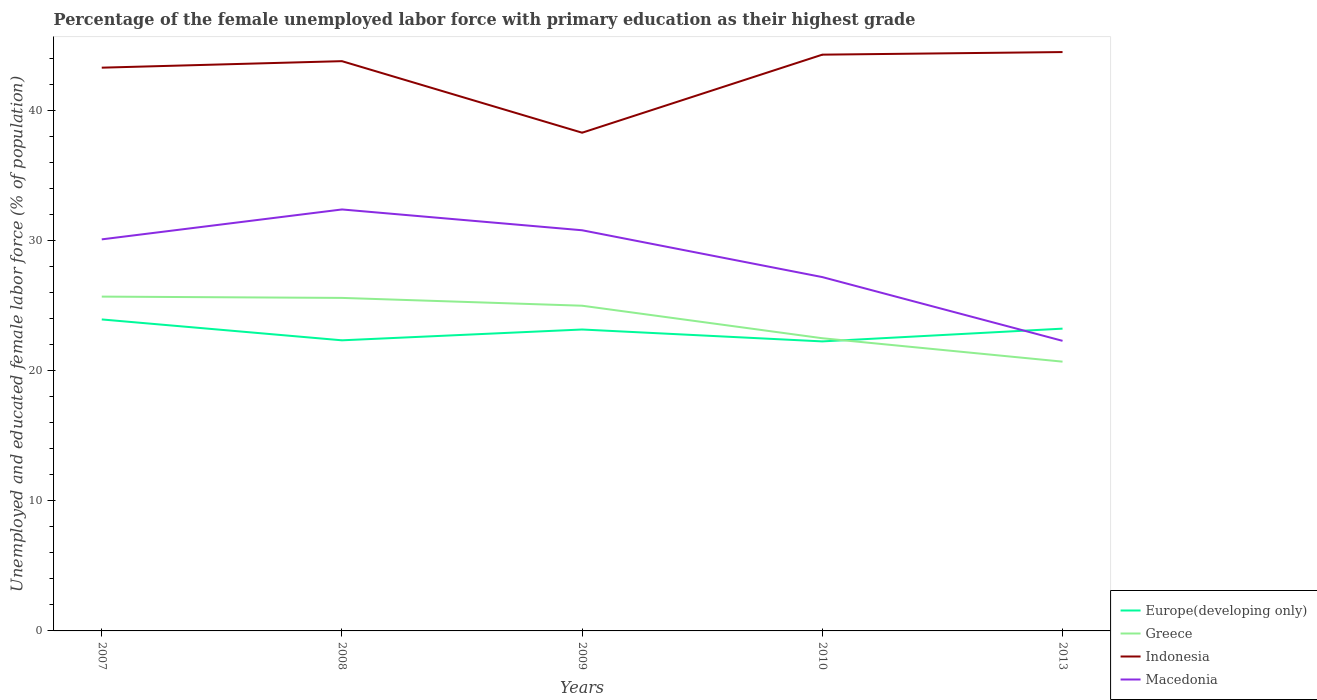Across all years, what is the maximum percentage of the unemployed female labor force with primary education in Indonesia?
Give a very brief answer. 38.3. In which year was the percentage of the unemployed female labor force with primary education in Greece maximum?
Provide a short and direct response. 2013. What is the total percentage of the unemployed female labor force with primary education in Europe(developing only) in the graph?
Your answer should be very brief. -0.83. What is the difference between the highest and the second highest percentage of the unemployed female labor force with primary education in Greece?
Provide a short and direct response. 5. Is the percentage of the unemployed female labor force with primary education in Europe(developing only) strictly greater than the percentage of the unemployed female labor force with primary education in Indonesia over the years?
Provide a succinct answer. Yes. How many lines are there?
Your response must be concise. 4. How many years are there in the graph?
Your answer should be very brief. 5. What is the difference between two consecutive major ticks on the Y-axis?
Your answer should be compact. 10. Where does the legend appear in the graph?
Offer a very short reply. Bottom right. How are the legend labels stacked?
Make the answer very short. Vertical. What is the title of the graph?
Provide a succinct answer. Percentage of the female unemployed labor force with primary education as their highest grade. Does "Netherlands" appear as one of the legend labels in the graph?
Give a very brief answer. No. What is the label or title of the X-axis?
Your response must be concise. Years. What is the label or title of the Y-axis?
Give a very brief answer. Unemployed and educated female labor force (% of population). What is the Unemployed and educated female labor force (% of population) of Europe(developing only) in 2007?
Ensure brevity in your answer.  23.95. What is the Unemployed and educated female labor force (% of population) of Greece in 2007?
Offer a very short reply. 25.7. What is the Unemployed and educated female labor force (% of population) in Indonesia in 2007?
Your response must be concise. 43.3. What is the Unemployed and educated female labor force (% of population) in Macedonia in 2007?
Ensure brevity in your answer.  30.1. What is the Unemployed and educated female labor force (% of population) in Europe(developing only) in 2008?
Your answer should be compact. 22.34. What is the Unemployed and educated female labor force (% of population) in Greece in 2008?
Offer a terse response. 25.6. What is the Unemployed and educated female labor force (% of population) in Indonesia in 2008?
Your response must be concise. 43.8. What is the Unemployed and educated female labor force (% of population) of Macedonia in 2008?
Make the answer very short. 32.4. What is the Unemployed and educated female labor force (% of population) of Europe(developing only) in 2009?
Offer a very short reply. 23.17. What is the Unemployed and educated female labor force (% of population) in Indonesia in 2009?
Provide a short and direct response. 38.3. What is the Unemployed and educated female labor force (% of population) in Macedonia in 2009?
Keep it short and to the point. 30.8. What is the Unemployed and educated female labor force (% of population) of Europe(developing only) in 2010?
Offer a terse response. 22.26. What is the Unemployed and educated female labor force (% of population) in Greece in 2010?
Your answer should be compact. 22.5. What is the Unemployed and educated female labor force (% of population) in Indonesia in 2010?
Keep it short and to the point. 44.3. What is the Unemployed and educated female labor force (% of population) in Macedonia in 2010?
Give a very brief answer. 27.2. What is the Unemployed and educated female labor force (% of population) in Europe(developing only) in 2013?
Offer a very short reply. 23.24. What is the Unemployed and educated female labor force (% of population) in Greece in 2013?
Ensure brevity in your answer.  20.7. What is the Unemployed and educated female labor force (% of population) in Indonesia in 2013?
Make the answer very short. 44.5. What is the Unemployed and educated female labor force (% of population) in Macedonia in 2013?
Keep it short and to the point. 22.3. Across all years, what is the maximum Unemployed and educated female labor force (% of population) of Europe(developing only)?
Your response must be concise. 23.95. Across all years, what is the maximum Unemployed and educated female labor force (% of population) in Greece?
Make the answer very short. 25.7. Across all years, what is the maximum Unemployed and educated female labor force (% of population) in Indonesia?
Your answer should be very brief. 44.5. Across all years, what is the maximum Unemployed and educated female labor force (% of population) of Macedonia?
Provide a short and direct response. 32.4. Across all years, what is the minimum Unemployed and educated female labor force (% of population) of Europe(developing only)?
Provide a succinct answer. 22.26. Across all years, what is the minimum Unemployed and educated female labor force (% of population) in Greece?
Your answer should be compact. 20.7. Across all years, what is the minimum Unemployed and educated female labor force (% of population) in Indonesia?
Keep it short and to the point. 38.3. Across all years, what is the minimum Unemployed and educated female labor force (% of population) in Macedonia?
Provide a short and direct response. 22.3. What is the total Unemployed and educated female labor force (% of population) of Europe(developing only) in the graph?
Offer a terse response. 114.95. What is the total Unemployed and educated female labor force (% of population) in Greece in the graph?
Give a very brief answer. 119.5. What is the total Unemployed and educated female labor force (% of population) of Indonesia in the graph?
Make the answer very short. 214.2. What is the total Unemployed and educated female labor force (% of population) of Macedonia in the graph?
Provide a succinct answer. 142.8. What is the difference between the Unemployed and educated female labor force (% of population) of Europe(developing only) in 2007 and that in 2008?
Your answer should be very brief. 1.6. What is the difference between the Unemployed and educated female labor force (% of population) in Greece in 2007 and that in 2008?
Your answer should be very brief. 0.1. What is the difference between the Unemployed and educated female labor force (% of population) of Europe(developing only) in 2007 and that in 2009?
Offer a terse response. 0.77. What is the difference between the Unemployed and educated female labor force (% of population) in Indonesia in 2007 and that in 2009?
Keep it short and to the point. 5. What is the difference between the Unemployed and educated female labor force (% of population) of Macedonia in 2007 and that in 2009?
Make the answer very short. -0.7. What is the difference between the Unemployed and educated female labor force (% of population) in Europe(developing only) in 2007 and that in 2010?
Make the answer very short. 1.69. What is the difference between the Unemployed and educated female labor force (% of population) of Greece in 2007 and that in 2010?
Offer a terse response. 3.2. What is the difference between the Unemployed and educated female labor force (% of population) of Europe(developing only) in 2007 and that in 2013?
Keep it short and to the point. 0.71. What is the difference between the Unemployed and educated female labor force (% of population) of Greece in 2007 and that in 2013?
Your answer should be very brief. 5. What is the difference between the Unemployed and educated female labor force (% of population) of Indonesia in 2007 and that in 2013?
Provide a succinct answer. -1.2. What is the difference between the Unemployed and educated female labor force (% of population) of Europe(developing only) in 2008 and that in 2009?
Give a very brief answer. -0.83. What is the difference between the Unemployed and educated female labor force (% of population) in Greece in 2008 and that in 2009?
Your response must be concise. 0.6. What is the difference between the Unemployed and educated female labor force (% of population) in Indonesia in 2008 and that in 2009?
Your answer should be very brief. 5.5. What is the difference between the Unemployed and educated female labor force (% of population) of Macedonia in 2008 and that in 2009?
Provide a succinct answer. 1.6. What is the difference between the Unemployed and educated female labor force (% of population) of Europe(developing only) in 2008 and that in 2010?
Provide a short and direct response. 0.08. What is the difference between the Unemployed and educated female labor force (% of population) of Europe(developing only) in 2008 and that in 2013?
Your answer should be compact. -0.9. What is the difference between the Unemployed and educated female labor force (% of population) in Greece in 2008 and that in 2013?
Offer a very short reply. 4.9. What is the difference between the Unemployed and educated female labor force (% of population) of Macedonia in 2008 and that in 2013?
Provide a short and direct response. 10.1. What is the difference between the Unemployed and educated female labor force (% of population) of Europe(developing only) in 2009 and that in 2010?
Provide a short and direct response. 0.92. What is the difference between the Unemployed and educated female labor force (% of population) of Macedonia in 2009 and that in 2010?
Keep it short and to the point. 3.6. What is the difference between the Unemployed and educated female labor force (% of population) of Europe(developing only) in 2009 and that in 2013?
Give a very brief answer. -0.07. What is the difference between the Unemployed and educated female labor force (% of population) of Europe(developing only) in 2010 and that in 2013?
Offer a terse response. -0.98. What is the difference between the Unemployed and educated female labor force (% of population) of Europe(developing only) in 2007 and the Unemployed and educated female labor force (% of population) of Greece in 2008?
Offer a terse response. -1.65. What is the difference between the Unemployed and educated female labor force (% of population) in Europe(developing only) in 2007 and the Unemployed and educated female labor force (% of population) in Indonesia in 2008?
Your answer should be compact. -19.85. What is the difference between the Unemployed and educated female labor force (% of population) in Europe(developing only) in 2007 and the Unemployed and educated female labor force (% of population) in Macedonia in 2008?
Ensure brevity in your answer.  -8.45. What is the difference between the Unemployed and educated female labor force (% of population) in Greece in 2007 and the Unemployed and educated female labor force (% of population) in Indonesia in 2008?
Offer a terse response. -18.1. What is the difference between the Unemployed and educated female labor force (% of population) in Greece in 2007 and the Unemployed and educated female labor force (% of population) in Macedonia in 2008?
Provide a short and direct response. -6.7. What is the difference between the Unemployed and educated female labor force (% of population) in Indonesia in 2007 and the Unemployed and educated female labor force (% of population) in Macedonia in 2008?
Provide a short and direct response. 10.9. What is the difference between the Unemployed and educated female labor force (% of population) in Europe(developing only) in 2007 and the Unemployed and educated female labor force (% of population) in Greece in 2009?
Offer a terse response. -1.05. What is the difference between the Unemployed and educated female labor force (% of population) of Europe(developing only) in 2007 and the Unemployed and educated female labor force (% of population) of Indonesia in 2009?
Provide a short and direct response. -14.35. What is the difference between the Unemployed and educated female labor force (% of population) of Europe(developing only) in 2007 and the Unemployed and educated female labor force (% of population) of Macedonia in 2009?
Ensure brevity in your answer.  -6.85. What is the difference between the Unemployed and educated female labor force (% of population) of Greece in 2007 and the Unemployed and educated female labor force (% of population) of Indonesia in 2009?
Your answer should be compact. -12.6. What is the difference between the Unemployed and educated female labor force (% of population) in Indonesia in 2007 and the Unemployed and educated female labor force (% of population) in Macedonia in 2009?
Your answer should be very brief. 12.5. What is the difference between the Unemployed and educated female labor force (% of population) in Europe(developing only) in 2007 and the Unemployed and educated female labor force (% of population) in Greece in 2010?
Provide a succinct answer. 1.45. What is the difference between the Unemployed and educated female labor force (% of population) in Europe(developing only) in 2007 and the Unemployed and educated female labor force (% of population) in Indonesia in 2010?
Provide a succinct answer. -20.35. What is the difference between the Unemployed and educated female labor force (% of population) in Europe(developing only) in 2007 and the Unemployed and educated female labor force (% of population) in Macedonia in 2010?
Provide a short and direct response. -3.25. What is the difference between the Unemployed and educated female labor force (% of population) in Greece in 2007 and the Unemployed and educated female labor force (% of population) in Indonesia in 2010?
Provide a short and direct response. -18.6. What is the difference between the Unemployed and educated female labor force (% of population) in Greece in 2007 and the Unemployed and educated female labor force (% of population) in Macedonia in 2010?
Provide a short and direct response. -1.5. What is the difference between the Unemployed and educated female labor force (% of population) in Indonesia in 2007 and the Unemployed and educated female labor force (% of population) in Macedonia in 2010?
Offer a terse response. 16.1. What is the difference between the Unemployed and educated female labor force (% of population) of Europe(developing only) in 2007 and the Unemployed and educated female labor force (% of population) of Greece in 2013?
Provide a succinct answer. 3.25. What is the difference between the Unemployed and educated female labor force (% of population) in Europe(developing only) in 2007 and the Unemployed and educated female labor force (% of population) in Indonesia in 2013?
Offer a terse response. -20.55. What is the difference between the Unemployed and educated female labor force (% of population) in Europe(developing only) in 2007 and the Unemployed and educated female labor force (% of population) in Macedonia in 2013?
Your answer should be compact. 1.65. What is the difference between the Unemployed and educated female labor force (% of population) of Greece in 2007 and the Unemployed and educated female labor force (% of population) of Indonesia in 2013?
Keep it short and to the point. -18.8. What is the difference between the Unemployed and educated female labor force (% of population) of Greece in 2007 and the Unemployed and educated female labor force (% of population) of Macedonia in 2013?
Provide a short and direct response. 3.4. What is the difference between the Unemployed and educated female labor force (% of population) in Europe(developing only) in 2008 and the Unemployed and educated female labor force (% of population) in Greece in 2009?
Ensure brevity in your answer.  -2.66. What is the difference between the Unemployed and educated female labor force (% of population) of Europe(developing only) in 2008 and the Unemployed and educated female labor force (% of population) of Indonesia in 2009?
Give a very brief answer. -15.96. What is the difference between the Unemployed and educated female labor force (% of population) in Europe(developing only) in 2008 and the Unemployed and educated female labor force (% of population) in Macedonia in 2009?
Your response must be concise. -8.46. What is the difference between the Unemployed and educated female labor force (% of population) of Europe(developing only) in 2008 and the Unemployed and educated female labor force (% of population) of Greece in 2010?
Make the answer very short. -0.16. What is the difference between the Unemployed and educated female labor force (% of population) of Europe(developing only) in 2008 and the Unemployed and educated female labor force (% of population) of Indonesia in 2010?
Your response must be concise. -21.96. What is the difference between the Unemployed and educated female labor force (% of population) of Europe(developing only) in 2008 and the Unemployed and educated female labor force (% of population) of Macedonia in 2010?
Your response must be concise. -4.86. What is the difference between the Unemployed and educated female labor force (% of population) of Greece in 2008 and the Unemployed and educated female labor force (% of population) of Indonesia in 2010?
Your answer should be very brief. -18.7. What is the difference between the Unemployed and educated female labor force (% of population) of Europe(developing only) in 2008 and the Unemployed and educated female labor force (% of population) of Greece in 2013?
Offer a terse response. 1.64. What is the difference between the Unemployed and educated female labor force (% of population) in Europe(developing only) in 2008 and the Unemployed and educated female labor force (% of population) in Indonesia in 2013?
Offer a very short reply. -22.16. What is the difference between the Unemployed and educated female labor force (% of population) of Europe(developing only) in 2008 and the Unemployed and educated female labor force (% of population) of Macedonia in 2013?
Your answer should be compact. 0.04. What is the difference between the Unemployed and educated female labor force (% of population) of Greece in 2008 and the Unemployed and educated female labor force (% of population) of Indonesia in 2013?
Keep it short and to the point. -18.9. What is the difference between the Unemployed and educated female labor force (% of population) of Europe(developing only) in 2009 and the Unemployed and educated female labor force (% of population) of Greece in 2010?
Your answer should be compact. 0.67. What is the difference between the Unemployed and educated female labor force (% of population) of Europe(developing only) in 2009 and the Unemployed and educated female labor force (% of population) of Indonesia in 2010?
Provide a succinct answer. -21.13. What is the difference between the Unemployed and educated female labor force (% of population) in Europe(developing only) in 2009 and the Unemployed and educated female labor force (% of population) in Macedonia in 2010?
Your answer should be compact. -4.03. What is the difference between the Unemployed and educated female labor force (% of population) in Greece in 2009 and the Unemployed and educated female labor force (% of population) in Indonesia in 2010?
Your response must be concise. -19.3. What is the difference between the Unemployed and educated female labor force (% of population) of Greece in 2009 and the Unemployed and educated female labor force (% of population) of Macedonia in 2010?
Provide a succinct answer. -2.2. What is the difference between the Unemployed and educated female labor force (% of population) in Europe(developing only) in 2009 and the Unemployed and educated female labor force (% of population) in Greece in 2013?
Your response must be concise. 2.47. What is the difference between the Unemployed and educated female labor force (% of population) in Europe(developing only) in 2009 and the Unemployed and educated female labor force (% of population) in Indonesia in 2013?
Your answer should be very brief. -21.33. What is the difference between the Unemployed and educated female labor force (% of population) of Europe(developing only) in 2009 and the Unemployed and educated female labor force (% of population) of Macedonia in 2013?
Offer a terse response. 0.87. What is the difference between the Unemployed and educated female labor force (% of population) in Greece in 2009 and the Unemployed and educated female labor force (% of population) in Indonesia in 2013?
Your answer should be very brief. -19.5. What is the difference between the Unemployed and educated female labor force (% of population) of Greece in 2009 and the Unemployed and educated female labor force (% of population) of Macedonia in 2013?
Keep it short and to the point. 2.7. What is the difference between the Unemployed and educated female labor force (% of population) of Indonesia in 2009 and the Unemployed and educated female labor force (% of population) of Macedonia in 2013?
Offer a very short reply. 16. What is the difference between the Unemployed and educated female labor force (% of population) of Europe(developing only) in 2010 and the Unemployed and educated female labor force (% of population) of Greece in 2013?
Offer a very short reply. 1.56. What is the difference between the Unemployed and educated female labor force (% of population) of Europe(developing only) in 2010 and the Unemployed and educated female labor force (% of population) of Indonesia in 2013?
Provide a short and direct response. -22.24. What is the difference between the Unemployed and educated female labor force (% of population) of Europe(developing only) in 2010 and the Unemployed and educated female labor force (% of population) of Macedonia in 2013?
Your answer should be very brief. -0.04. What is the difference between the Unemployed and educated female labor force (% of population) of Greece in 2010 and the Unemployed and educated female labor force (% of population) of Indonesia in 2013?
Make the answer very short. -22. What is the average Unemployed and educated female labor force (% of population) in Europe(developing only) per year?
Your answer should be compact. 22.99. What is the average Unemployed and educated female labor force (% of population) of Greece per year?
Offer a terse response. 23.9. What is the average Unemployed and educated female labor force (% of population) of Indonesia per year?
Ensure brevity in your answer.  42.84. What is the average Unemployed and educated female labor force (% of population) in Macedonia per year?
Your answer should be very brief. 28.56. In the year 2007, what is the difference between the Unemployed and educated female labor force (% of population) of Europe(developing only) and Unemployed and educated female labor force (% of population) of Greece?
Your response must be concise. -1.75. In the year 2007, what is the difference between the Unemployed and educated female labor force (% of population) in Europe(developing only) and Unemployed and educated female labor force (% of population) in Indonesia?
Give a very brief answer. -19.35. In the year 2007, what is the difference between the Unemployed and educated female labor force (% of population) of Europe(developing only) and Unemployed and educated female labor force (% of population) of Macedonia?
Your answer should be compact. -6.15. In the year 2007, what is the difference between the Unemployed and educated female labor force (% of population) of Greece and Unemployed and educated female labor force (% of population) of Indonesia?
Keep it short and to the point. -17.6. In the year 2007, what is the difference between the Unemployed and educated female labor force (% of population) in Greece and Unemployed and educated female labor force (% of population) in Macedonia?
Keep it short and to the point. -4.4. In the year 2007, what is the difference between the Unemployed and educated female labor force (% of population) of Indonesia and Unemployed and educated female labor force (% of population) of Macedonia?
Keep it short and to the point. 13.2. In the year 2008, what is the difference between the Unemployed and educated female labor force (% of population) in Europe(developing only) and Unemployed and educated female labor force (% of population) in Greece?
Give a very brief answer. -3.26. In the year 2008, what is the difference between the Unemployed and educated female labor force (% of population) in Europe(developing only) and Unemployed and educated female labor force (% of population) in Indonesia?
Keep it short and to the point. -21.46. In the year 2008, what is the difference between the Unemployed and educated female labor force (% of population) in Europe(developing only) and Unemployed and educated female labor force (% of population) in Macedonia?
Offer a terse response. -10.06. In the year 2008, what is the difference between the Unemployed and educated female labor force (% of population) in Greece and Unemployed and educated female labor force (% of population) in Indonesia?
Your answer should be compact. -18.2. In the year 2008, what is the difference between the Unemployed and educated female labor force (% of population) of Greece and Unemployed and educated female labor force (% of population) of Macedonia?
Offer a very short reply. -6.8. In the year 2008, what is the difference between the Unemployed and educated female labor force (% of population) in Indonesia and Unemployed and educated female labor force (% of population) in Macedonia?
Your response must be concise. 11.4. In the year 2009, what is the difference between the Unemployed and educated female labor force (% of population) in Europe(developing only) and Unemployed and educated female labor force (% of population) in Greece?
Provide a short and direct response. -1.83. In the year 2009, what is the difference between the Unemployed and educated female labor force (% of population) in Europe(developing only) and Unemployed and educated female labor force (% of population) in Indonesia?
Keep it short and to the point. -15.13. In the year 2009, what is the difference between the Unemployed and educated female labor force (% of population) in Europe(developing only) and Unemployed and educated female labor force (% of population) in Macedonia?
Your answer should be compact. -7.63. In the year 2009, what is the difference between the Unemployed and educated female labor force (% of population) in Greece and Unemployed and educated female labor force (% of population) in Indonesia?
Give a very brief answer. -13.3. In the year 2009, what is the difference between the Unemployed and educated female labor force (% of population) of Indonesia and Unemployed and educated female labor force (% of population) of Macedonia?
Ensure brevity in your answer.  7.5. In the year 2010, what is the difference between the Unemployed and educated female labor force (% of population) in Europe(developing only) and Unemployed and educated female labor force (% of population) in Greece?
Your answer should be very brief. -0.24. In the year 2010, what is the difference between the Unemployed and educated female labor force (% of population) of Europe(developing only) and Unemployed and educated female labor force (% of population) of Indonesia?
Provide a short and direct response. -22.04. In the year 2010, what is the difference between the Unemployed and educated female labor force (% of population) of Europe(developing only) and Unemployed and educated female labor force (% of population) of Macedonia?
Provide a short and direct response. -4.94. In the year 2010, what is the difference between the Unemployed and educated female labor force (% of population) of Greece and Unemployed and educated female labor force (% of population) of Indonesia?
Offer a very short reply. -21.8. In the year 2013, what is the difference between the Unemployed and educated female labor force (% of population) in Europe(developing only) and Unemployed and educated female labor force (% of population) in Greece?
Provide a succinct answer. 2.54. In the year 2013, what is the difference between the Unemployed and educated female labor force (% of population) in Europe(developing only) and Unemployed and educated female labor force (% of population) in Indonesia?
Your response must be concise. -21.26. In the year 2013, what is the difference between the Unemployed and educated female labor force (% of population) in Europe(developing only) and Unemployed and educated female labor force (% of population) in Macedonia?
Make the answer very short. 0.94. In the year 2013, what is the difference between the Unemployed and educated female labor force (% of population) in Greece and Unemployed and educated female labor force (% of population) in Indonesia?
Offer a terse response. -23.8. In the year 2013, what is the difference between the Unemployed and educated female labor force (% of population) of Greece and Unemployed and educated female labor force (% of population) of Macedonia?
Your answer should be very brief. -1.6. What is the ratio of the Unemployed and educated female labor force (% of population) of Europe(developing only) in 2007 to that in 2008?
Give a very brief answer. 1.07. What is the ratio of the Unemployed and educated female labor force (% of population) in Indonesia in 2007 to that in 2008?
Offer a terse response. 0.99. What is the ratio of the Unemployed and educated female labor force (% of population) in Macedonia in 2007 to that in 2008?
Keep it short and to the point. 0.93. What is the ratio of the Unemployed and educated female labor force (% of population) in Europe(developing only) in 2007 to that in 2009?
Your response must be concise. 1.03. What is the ratio of the Unemployed and educated female labor force (% of population) of Greece in 2007 to that in 2009?
Your answer should be very brief. 1.03. What is the ratio of the Unemployed and educated female labor force (% of population) of Indonesia in 2007 to that in 2009?
Offer a very short reply. 1.13. What is the ratio of the Unemployed and educated female labor force (% of population) in Macedonia in 2007 to that in 2009?
Your answer should be compact. 0.98. What is the ratio of the Unemployed and educated female labor force (% of population) in Europe(developing only) in 2007 to that in 2010?
Offer a very short reply. 1.08. What is the ratio of the Unemployed and educated female labor force (% of population) in Greece in 2007 to that in 2010?
Offer a very short reply. 1.14. What is the ratio of the Unemployed and educated female labor force (% of population) in Indonesia in 2007 to that in 2010?
Your answer should be very brief. 0.98. What is the ratio of the Unemployed and educated female labor force (% of population) in Macedonia in 2007 to that in 2010?
Make the answer very short. 1.11. What is the ratio of the Unemployed and educated female labor force (% of population) of Europe(developing only) in 2007 to that in 2013?
Keep it short and to the point. 1.03. What is the ratio of the Unemployed and educated female labor force (% of population) in Greece in 2007 to that in 2013?
Make the answer very short. 1.24. What is the ratio of the Unemployed and educated female labor force (% of population) of Macedonia in 2007 to that in 2013?
Your answer should be compact. 1.35. What is the ratio of the Unemployed and educated female labor force (% of population) in Europe(developing only) in 2008 to that in 2009?
Offer a terse response. 0.96. What is the ratio of the Unemployed and educated female labor force (% of population) of Greece in 2008 to that in 2009?
Keep it short and to the point. 1.02. What is the ratio of the Unemployed and educated female labor force (% of population) of Indonesia in 2008 to that in 2009?
Offer a very short reply. 1.14. What is the ratio of the Unemployed and educated female labor force (% of population) in Macedonia in 2008 to that in 2009?
Provide a short and direct response. 1.05. What is the ratio of the Unemployed and educated female labor force (% of population) of Europe(developing only) in 2008 to that in 2010?
Offer a very short reply. 1. What is the ratio of the Unemployed and educated female labor force (% of population) of Greece in 2008 to that in 2010?
Your response must be concise. 1.14. What is the ratio of the Unemployed and educated female labor force (% of population) in Indonesia in 2008 to that in 2010?
Provide a succinct answer. 0.99. What is the ratio of the Unemployed and educated female labor force (% of population) of Macedonia in 2008 to that in 2010?
Provide a succinct answer. 1.19. What is the ratio of the Unemployed and educated female labor force (% of population) of Europe(developing only) in 2008 to that in 2013?
Offer a terse response. 0.96. What is the ratio of the Unemployed and educated female labor force (% of population) of Greece in 2008 to that in 2013?
Your answer should be compact. 1.24. What is the ratio of the Unemployed and educated female labor force (% of population) in Indonesia in 2008 to that in 2013?
Make the answer very short. 0.98. What is the ratio of the Unemployed and educated female labor force (% of population) of Macedonia in 2008 to that in 2013?
Make the answer very short. 1.45. What is the ratio of the Unemployed and educated female labor force (% of population) in Europe(developing only) in 2009 to that in 2010?
Your answer should be very brief. 1.04. What is the ratio of the Unemployed and educated female labor force (% of population) in Greece in 2009 to that in 2010?
Keep it short and to the point. 1.11. What is the ratio of the Unemployed and educated female labor force (% of population) in Indonesia in 2009 to that in 2010?
Ensure brevity in your answer.  0.86. What is the ratio of the Unemployed and educated female labor force (% of population) in Macedonia in 2009 to that in 2010?
Provide a succinct answer. 1.13. What is the ratio of the Unemployed and educated female labor force (% of population) of Greece in 2009 to that in 2013?
Provide a succinct answer. 1.21. What is the ratio of the Unemployed and educated female labor force (% of population) in Indonesia in 2009 to that in 2013?
Your answer should be compact. 0.86. What is the ratio of the Unemployed and educated female labor force (% of population) in Macedonia in 2009 to that in 2013?
Provide a succinct answer. 1.38. What is the ratio of the Unemployed and educated female labor force (% of population) in Europe(developing only) in 2010 to that in 2013?
Your answer should be very brief. 0.96. What is the ratio of the Unemployed and educated female labor force (% of population) in Greece in 2010 to that in 2013?
Your answer should be compact. 1.09. What is the ratio of the Unemployed and educated female labor force (% of population) in Indonesia in 2010 to that in 2013?
Provide a succinct answer. 1. What is the ratio of the Unemployed and educated female labor force (% of population) of Macedonia in 2010 to that in 2013?
Offer a terse response. 1.22. What is the difference between the highest and the second highest Unemployed and educated female labor force (% of population) in Europe(developing only)?
Provide a succinct answer. 0.71. What is the difference between the highest and the second highest Unemployed and educated female labor force (% of population) of Indonesia?
Your response must be concise. 0.2. What is the difference between the highest and the lowest Unemployed and educated female labor force (% of population) in Europe(developing only)?
Keep it short and to the point. 1.69. 